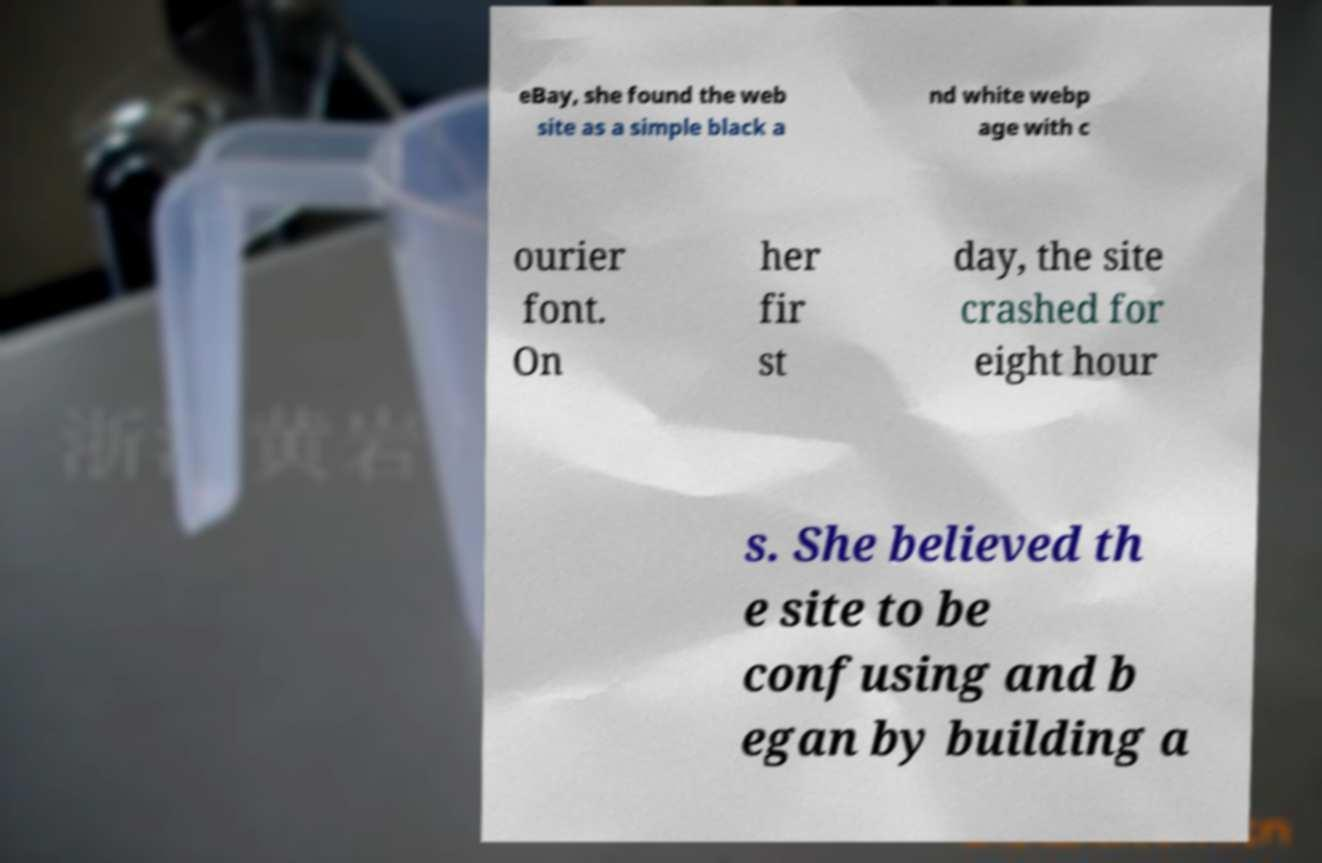Can you read and provide the text displayed in the image?This photo seems to have some interesting text. Can you extract and type it out for me? eBay, she found the web site as a simple black a nd white webp age with c ourier font. On her fir st day, the site crashed for eight hour s. She believed th e site to be confusing and b egan by building a 